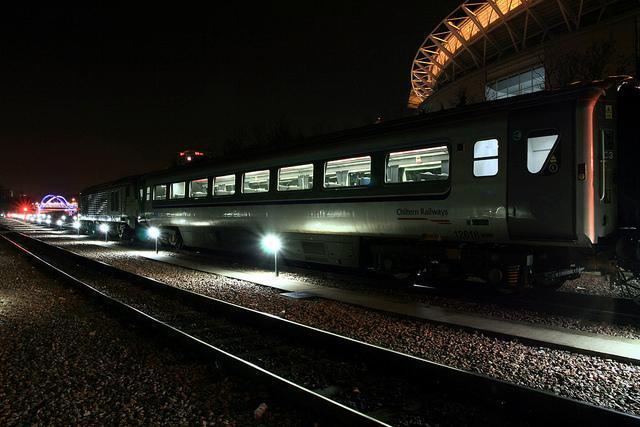How many people are wearing skis in this image?
Give a very brief answer. 0. 